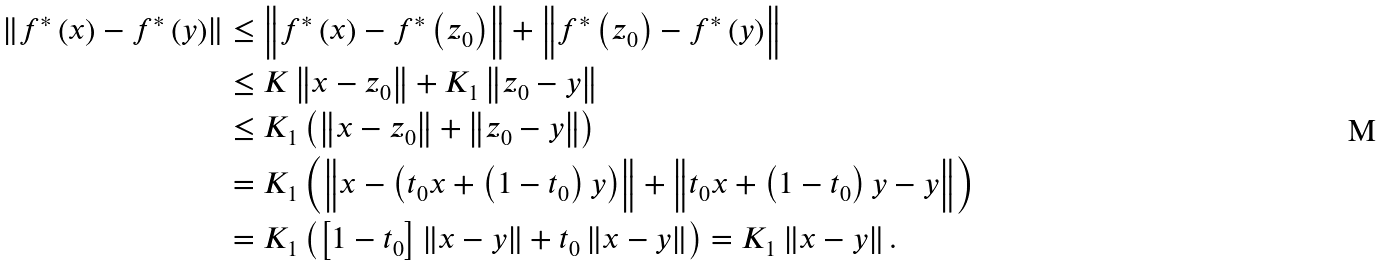Convert formula to latex. <formula><loc_0><loc_0><loc_500><loc_500>\left \| f ^ { \ast } \left ( x \right ) - f ^ { \ast } \left ( y \right ) \right \| & \leq \left \| f ^ { \ast } \left ( x \right ) - f ^ { \ast } \left ( z _ { 0 } \right ) \right \| + \left \| f ^ { \ast } \left ( z _ { 0 } \right ) - f ^ { \ast } \left ( y \right ) \right \| \\ & \leq K \left \| x - z _ { 0 } \right \| + K _ { 1 } \left \| z _ { 0 } - y \right \| \\ & \leq K _ { 1 } \left ( \left \| x - z _ { 0 } \right \| + \left \| z _ { 0 } - y \right \| \right ) \\ & = K _ { 1 } \left ( \left \| x - \left ( t _ { 0 } x + \left ( 1 - t _ { 0 } \right ) y \right ) \right \| + \left \| t _ { 0 } x + \left ( 1 - t _ { 0 } \right ) y - y \right \| \right ) \\ & = K _ { 1 } \left ( \left [ 1 - t _ { 0 } \right ] \left \| x - y \right \| + t _ { 0 } \left \| x - y \right \| \right ) = K _ { 1 } \left \| x - y \right \| .</formula> 